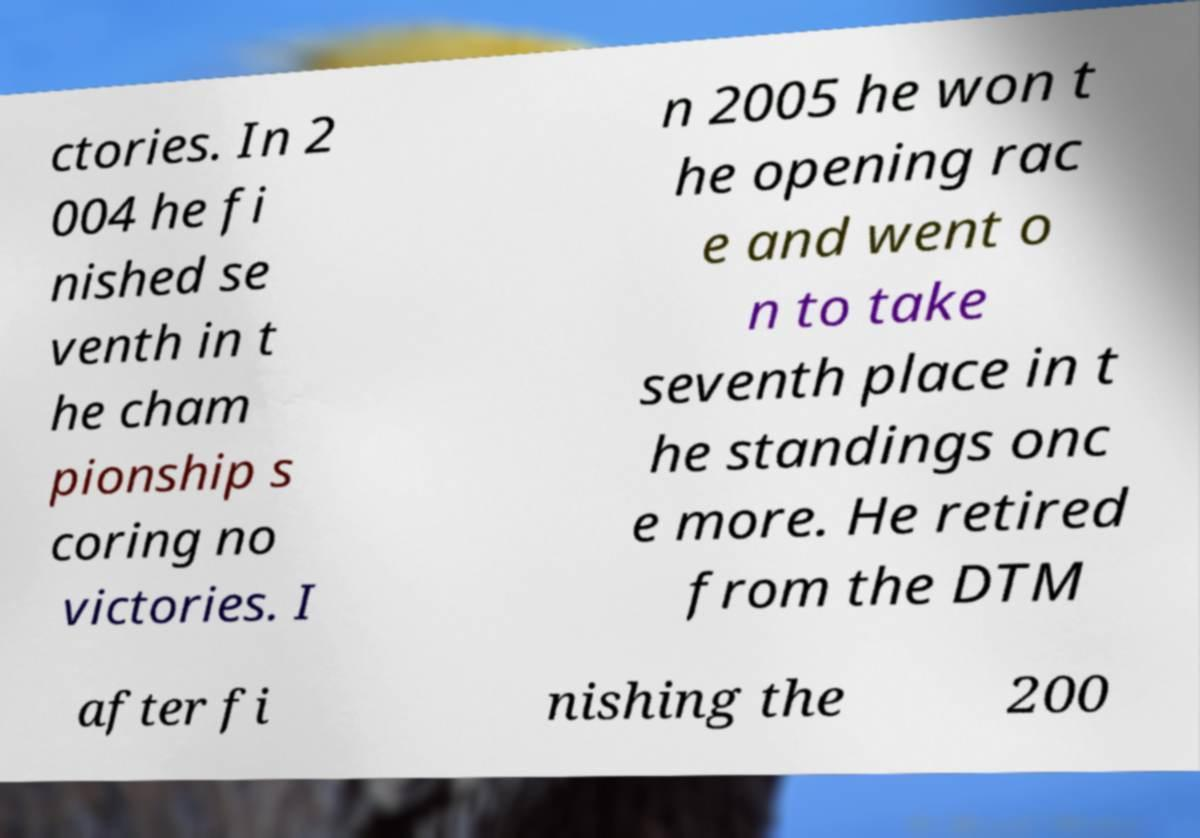What messages or text are displayed in this image? I need them in a readable, typed format. ctories. In 2 004 he fi nished se venth in t he cham pionship s coring no victories. I n 2005 he won t he opening rac e and went o n to take seventh place in t he standings onc e more. He retired from the DTM after fi nishing the 200 